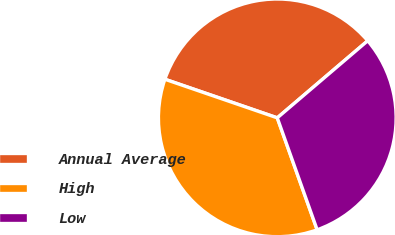Convert chart to OTSL. <chart><loc_0><loc_0><loc_500><loc_500><pie_chart><fcel>Annual Average<fcel>High<fcel>Low<nl><fcel>33.5%<fcel>35.71%<fcel>30.79%<nl></chart> 